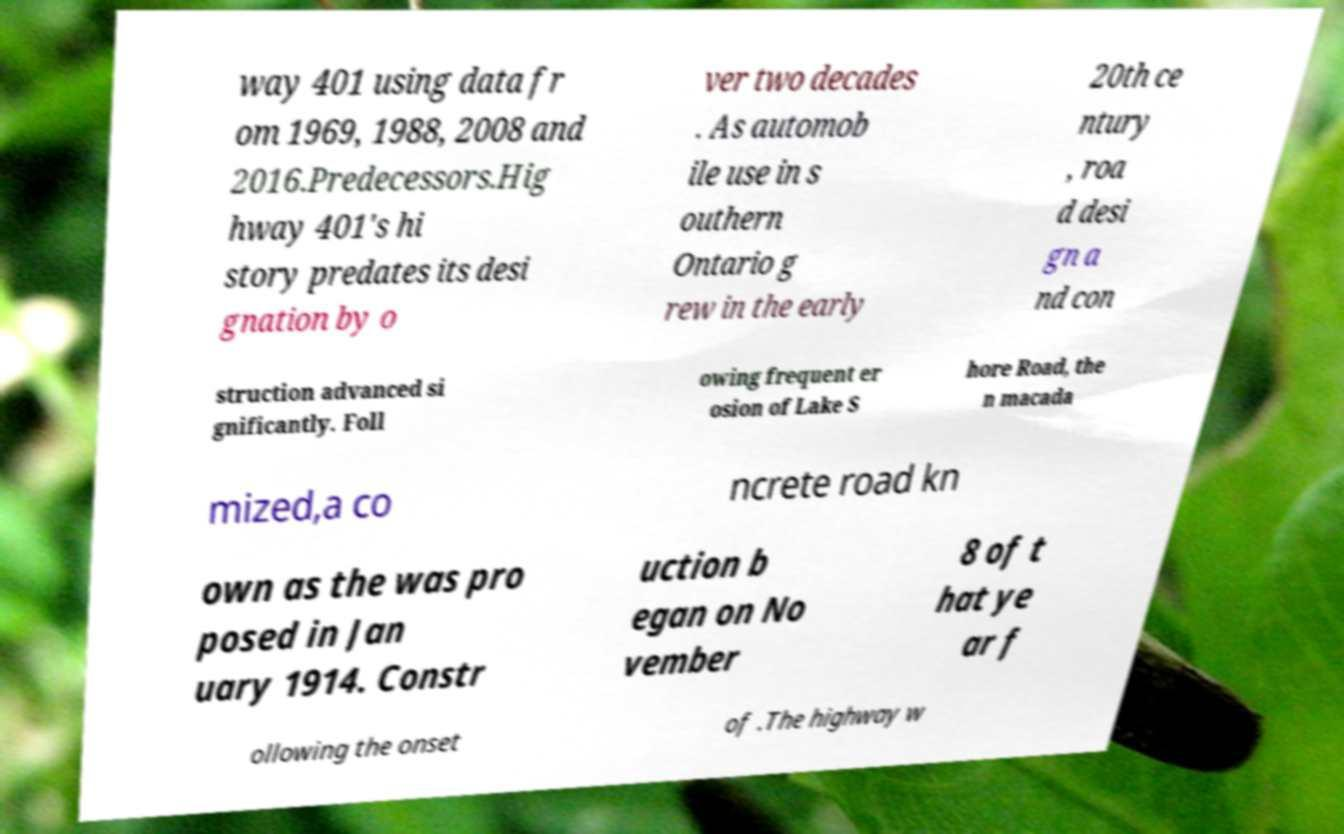Can you read and provide the text displayed in the image?This photo seems to have some interesting text. Can you extract and type it out for me? way 401 using data fr om 1969, 1988, 2008 and 2016.Predecessors.Hig hway 401's hi story predates its desi gnation by o ver two decades . As automob ile use in s outhern Ontario g rew in the early 20th ce ntury , roa d desi gn a nd con struction advanced si gnificantly. Foll owing frequent er osion of Lake S hore Road, the n macada mized,a co ncrete road kn own as the was pro posed in Jan uary 1914. Constr uction b egan on No vember 8 of t hat ye ar f ollowing the onset of .The highway w 